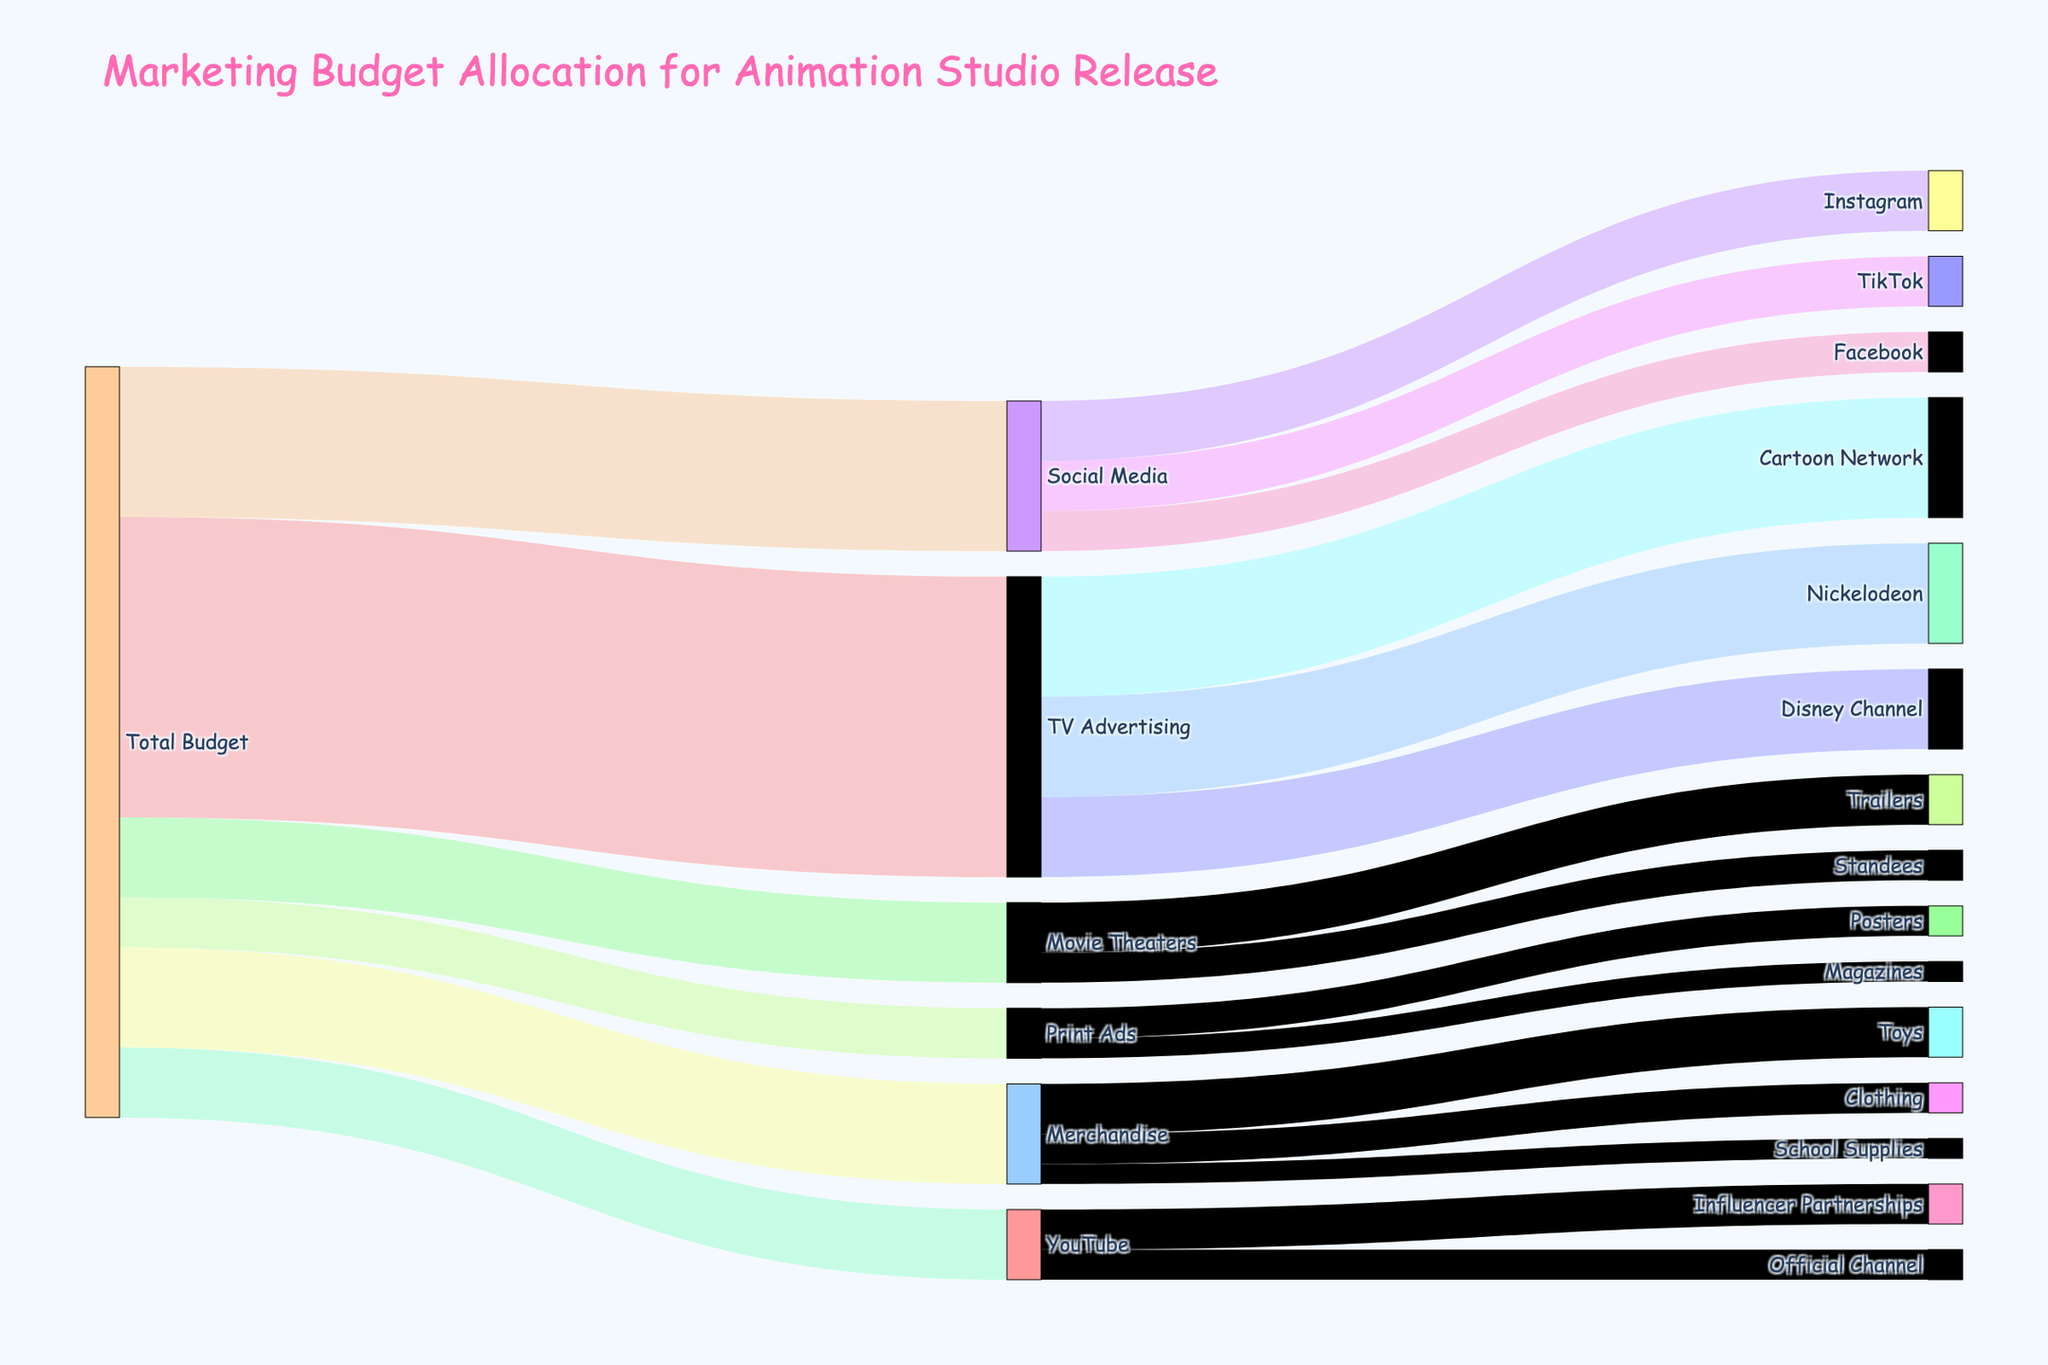What's the title of the figure? The title of the figure is usually placed at the top and is formatted with larger and bold text. It's designed to give an overview of what the figure represents.
Answer: "Marketing Budget Allocation for Animation Studio Release" What is the total budget allocated to TV Advertising? Check the diagram to see the flow from "Total Budget" to "TV Advertising". The value next to this flow represents the budget allocated.
Answer: 30,000,000 Which category received the smallest budget allocation? Look at all the direct flows from "Total Budget" to each category. Identify the flow with the smallest value.
Answer: Print Ads How much total budget is allocated to social media platforms? Sum the budgets flowing from "Social Media" to Instagram, TikTok, and Facebook.
Answer: 15,000,000 What is the difference in budget allocation between YouTube's Influencer Partnerships and its Official Channel? Subtract the budget of the Official Channel from that of Influencer Partnerships.
Answer: 1,000,000 Which TV network received the highest budget from TV Advertising? Check the flows from "TV Advertising" to Cartoon Network, Nickelodeon, and Disney Channel, and find the highest value.
Answer: Cartoon Network Compare the budget allocated to Merchandise's Clothing and School Supplies. Which one received more? Look at the values in the flows from "Merchandise" to "Clothing" and "School Supplies," and compare them.
Answer: Clothing How much total budget is allocated to all platforms within "Movie Theaters"? Sum the budget allocated to Trailers and Standees under "Movie Theaters".
Answer: 8,000,000 How does the budget for Print Ads compare to Merchandise? Compare the value of the flows from "Total Budget" to Print Ads and Merchandise.
Answer: Merchandise has more than Print Ads What proportion of the total budget was allocated to YouTube? Compare the budget flow from "Total Budget" to YouTube with the total sum of all flows from "Total Budget".
Answer: 7,000,000 / 75,000,000 = 9.33% 